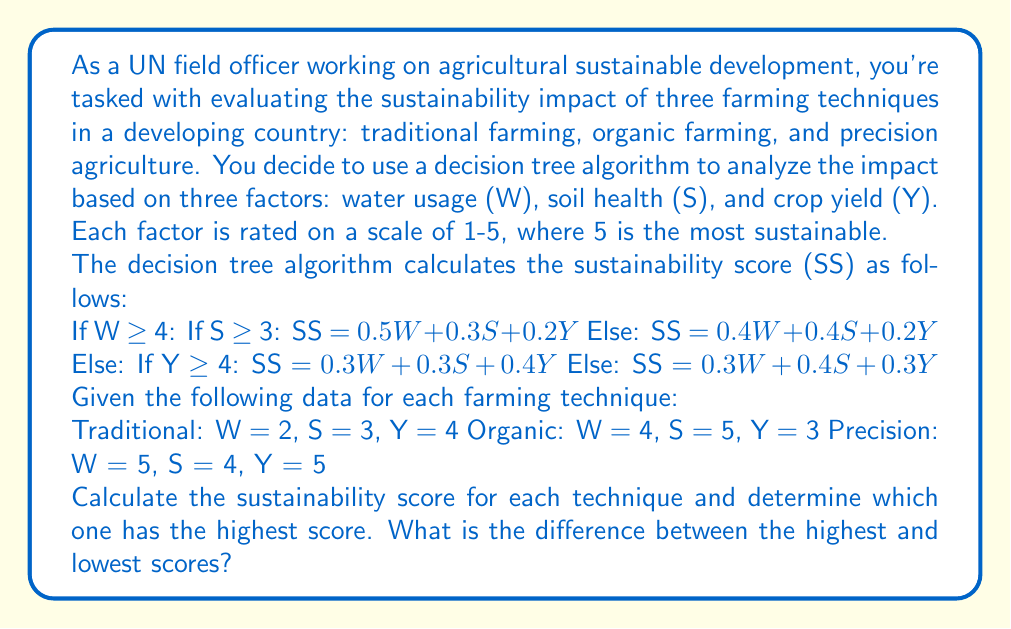Provide a solution to this math problem. To solve this problem, we need to calculate the sustainability score (SS) for each farming technique using the given decision tree algorithm. Let's go through each technique step by step:

1. Traditional Farming (W = 2, S = 3, Y = 4):
   Since W < 4, we check if Y ≥ 4.
   Y = 4, so we use the formula: SS = $0.3W + 0.3S + 0.4Y$
   SS = $0.3(2) + 0.3(3) + 0.4(4)$
   SS = $0.6 + 0.9 + 1.6 = 3.1$

2. Organic Farming (W = 4, S = 5, Y = 3):
   Since W ≥ 4, we check if S ≥ 3.
   S = 5, so we use the formula: SS = $0.5W + 0.3S + 0.2Y$
   SS = $0.5(4) + 0.3(5) + 0.2(3)$
   SS = $2 + 1.5 + 0.6 = 4.1$

3. Precision Agriculture (W = 5, S = 4, Y = 5):
   Since W ≥ 4, we check if S ≥ 3.
   S = 4, so we use the formula: SS = $0.5W + 0.3S + 0.2Y$
   SS = $0.5(5) + 0.3(4) + 0.2(5)$
   SS = $2.5 + 1.2 + 1 = 4.7$

Now, we can compare the sustainability scores:
Traditional: 3.1
Organic: 4.1
Precision: 4.7

The highest score is 4.7 for Precision Agriculture.
The lowest score is 3.1 for Traditional Farming.

To find the difference between the highest and lowest scores:
$4.7 - 3.1 = 1.6$
Answer: Precision Agriculture has the highest sustainability score of 4.7. The difference between the highest and lowest scores is 1.6. 